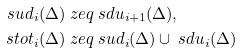Convert formula to latex. <formula><loc_0><loc_0><loc_500><loc_500>\ s u d _ { i } ( \Delta ) & \ z e q \ s d u _ { i + 1 } ( \Delta ) , \\ \ s t o t _ { i } ( \Delta ) & \ z e q \ s u d _ { i } ( \Delta ) \cup \ s d u _ { i } ( \Delta )</formula> 